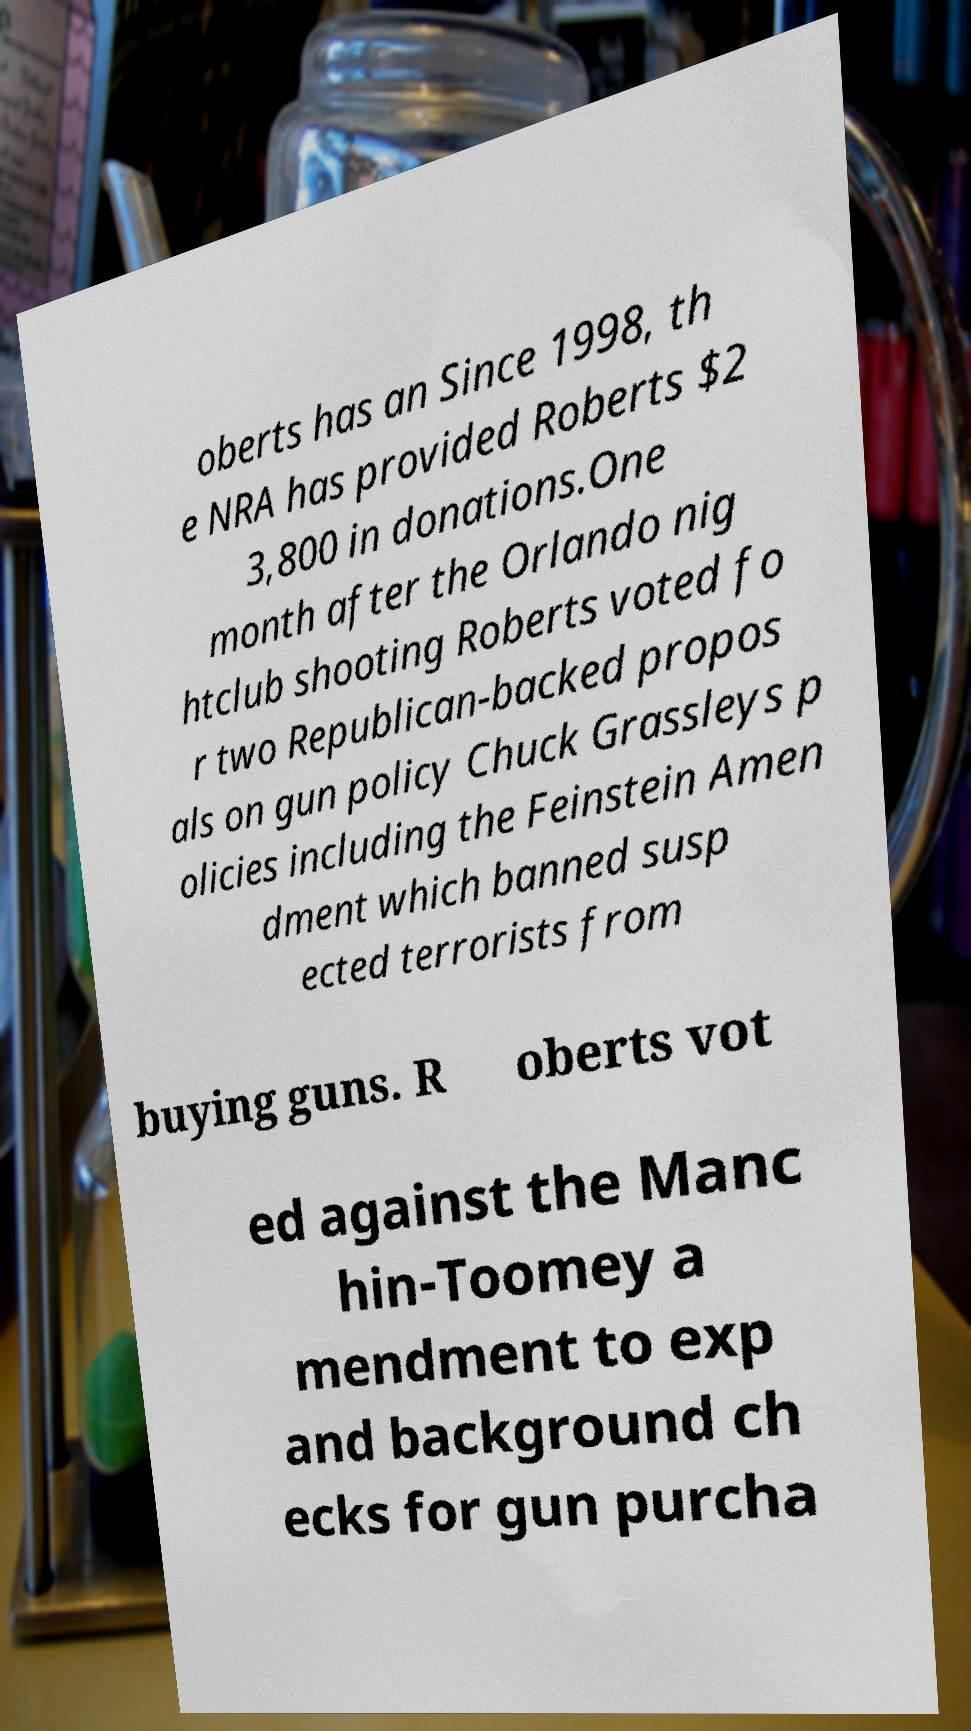Can you read and provide the text displayed in the image?This photo seems to have some interesting text. Can you extract and type it out for me? oberts has an Since 1998, th e NRA has provided Roberts $2 3,800 in donations.One month after the Orlando nig htclub shooting Roberts voted fo r two Republican-backed propos als on gun policy Chuck Grassleys p olicies including the Feinstein Amen dment which banned susp ected terrorists from buying guns. R oberts vot ed against the Manc hin-Toomey a mendment to exp and background ch ecks for gun purcha 